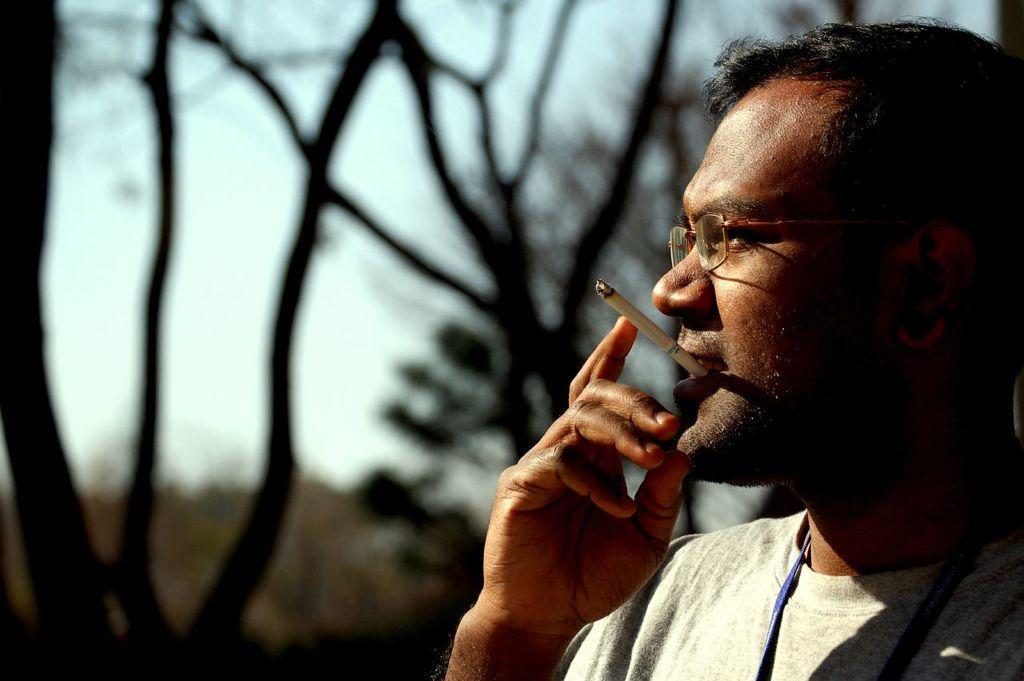Describe this image in one or two sentences. In this image I see a man and I see cigarette in his mouth and I see that it is blurred in the background and I see that he is wearing a t-shirt. 